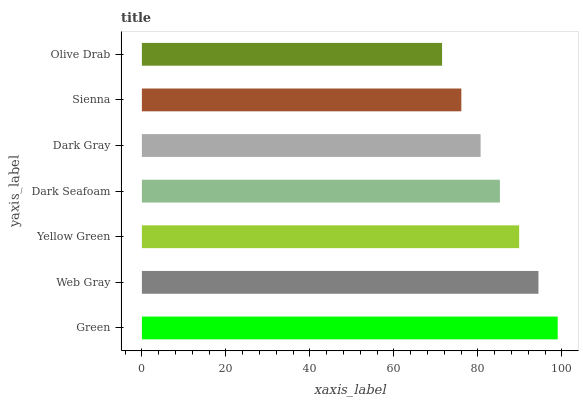Is Olive Drab the minimum?
Answer yes or no. Yes. Is Green the maximum?
Answer yes or no. Yes. Is Web Gray the minimum?
Answer yes or no. No. Is Web Gray the maximum?
Answer yes or no. No. Is Green greater than Web Gray?
Answer yes or no. Yes. Is Web Gray less than Green?
Answer yes or no. Yes. Is Web Gray greater than Green?
Answer yes or no. No. Is Green less than Web Gray?
Answer yes or no. No. Is Dark Seafoam the high median?
Answer yes or no. Yes. Is Dark Seafoam the low median?
Answer yes or no. Yes. Is Web Gray the high median?
Answer yes or no. No. Is Sienna the low median?
Answer yes or no. No. 